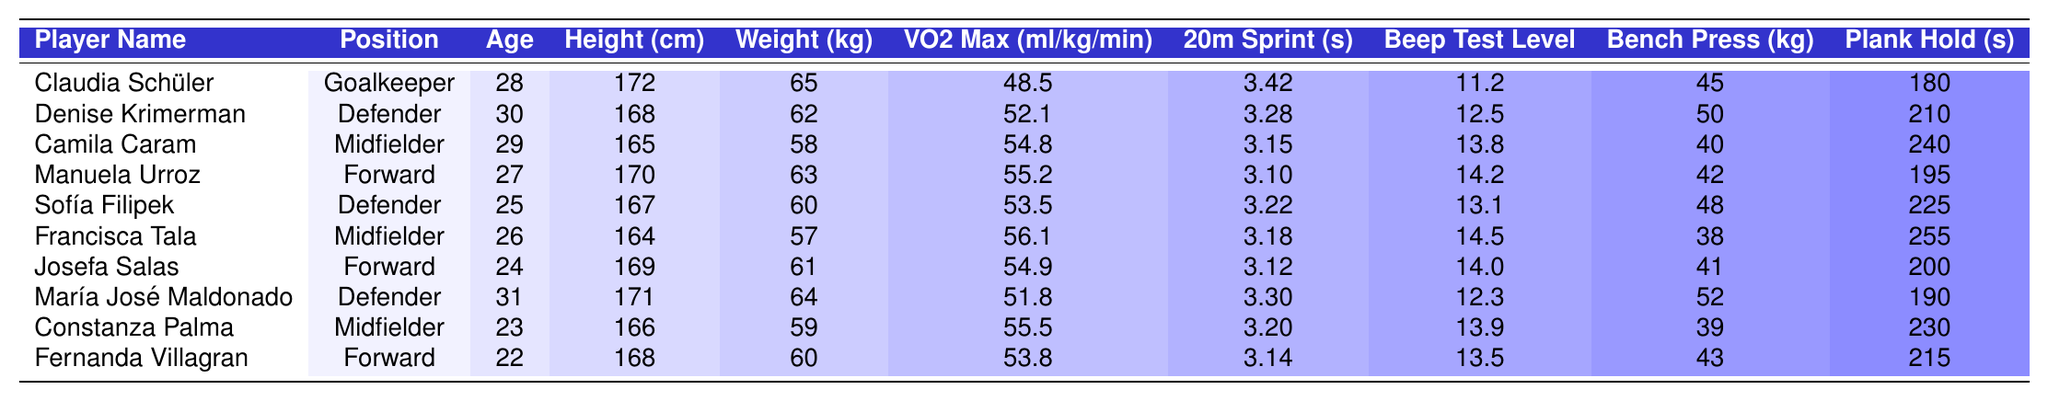What is the average weight of the players in the team? To find the average weight, we add all the players' weights together: (65 + 62 + 58 + 63 + 60 + 57 + 61 + 64 + 59 + 60) = 617 kg. There are 10 players, so the average weight is 617 kg / 10 = 61.7 kg.
Answer: 61.7 kg Which player has the highest VO2 Max? From the table, we look through the VO2 Max values and find that Francisca Tala has the highest VO2 Max at 56.1 ml/kg/min.
Answer: Francisca Tala How many players have a bench press over 45 kg? We count the players with bench press values above 45 kg: Claudia Schüler, Denise Krimerman, Manuela Urroz, María José Maldonado, Sofía Filipek, and Francisca Tala — that makes it 6 players.
Answer: 6 players Is the average age of the players over 26 years? First, we calculate the average age: (28 + 30 + 29 + 27 + 25 + 26 + 24 + 31 + 23 + 22) =  25 + 27 + 29 + 30 + 31 = 287 years. Dividing by 10 (the number of players) gives 28.7, which is over 26. Therefore, the statement is true.
Answer: Yes Who is the youngest player on the team? By examining the ages of the players, we find that Fernanda Villagran is 22 years old, making her the youngest player.
Answer: Fernanda Villagran What is the difference in height between the tallest and shortest players? The tallest player is Claudia Schüler at 172 cm, and the shortest is Francisca Tala at 164 cm. We calculate the difference: 172 cm - 164 cm = 8 cm.
Answer: 8 cm How many players can hold the plank for more than 200 seconds? We check the plank hold times and see that only Camila Caram (240 seconds), Francisca Tala (255 seconds), and Sofía Filipek (225 seconds) can hold it for more than 200 seconds. That makes it 3 players.
Answer: 3 players Is there a player whose 20m sprint time is below 3.2 seconds? Looking through the 20m sprint times, we see that Claudia Schüler (3.42), Denise Krimerman (3.28), Camila Caram (3.15), Manuela Urroz (3.10), Sofía Filipek (3.22), and others exceed 3.2 seconds, thus no player is below this time. Therefore, the answer is false.
Answer: No What is the average Benchn Press for Forward players? The forward players are Manuela Urroz (42 kg), Josefa Salas (41 kg), and Fernanda Villagran (43 kg). Adding these gives 42 + 41 + 43 = 126 kg. Dividing this by 3 (the number of forwards), we find the average: 126 kg / 3 = 42 kg.
Answer: 42 kg Which player has the best Beep Test Level? From the table, we see that Denise Krimerman has the best Beep Test Level at 12.5.
Answer: Denise Krimerman 